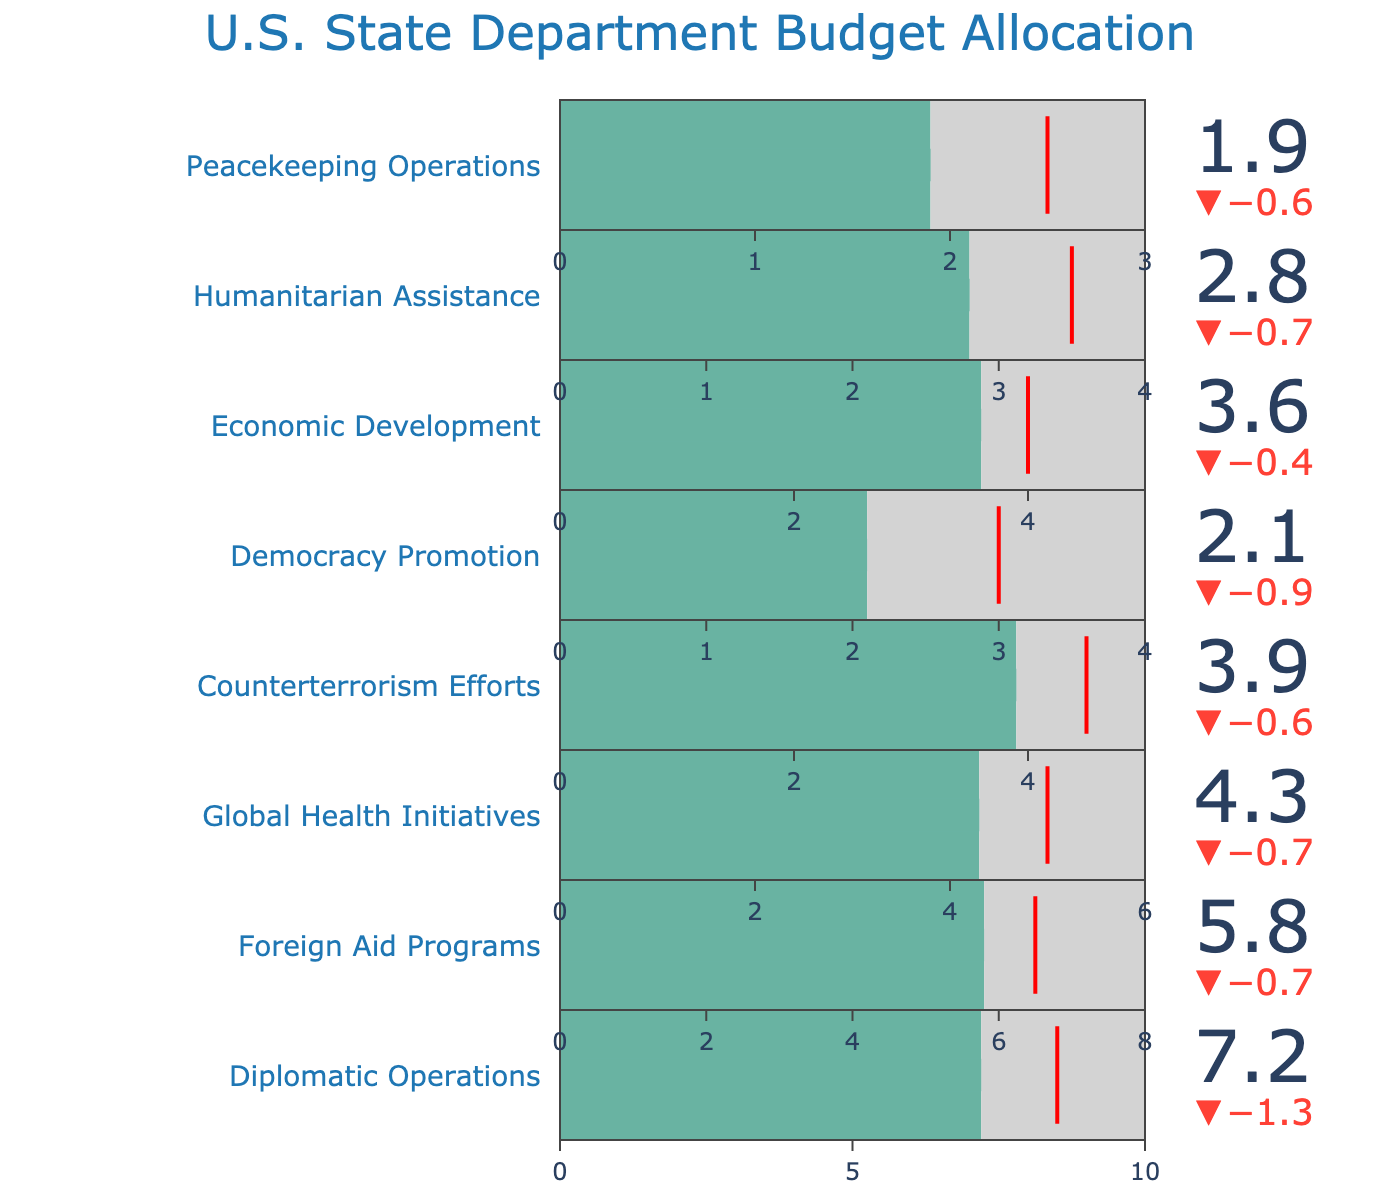What is the actual budget for Diplomatic Operations? The figure shows Diplomatic Operations with an actual budget value indicator. By looking at the actual value in the bullet chart for Diplomatic Operations, we can see it is 7.2.
Answer: 7.2 What category has the largest difference between actual spending and target spending? To determine the category with the largest difference, we need to compare the delta values (the difference) for each category. The differences are as follows: Diplomatic Operations: 1.3 (8.5 - 7.2), Foreign Aid Programs: 0.7 (6.5 - 5.8), Global Health Initiatives: 0.7 (5.0 - 4.3), Counterterrorism Efforts: 0.6 (4.5 - 3.9), Democracy Promotion: 0.9 (3.0 - 2.1), Economic Development: 0.4 (4.0 - 3.6), Humanitarian Assistance: 0.7 (3.5 - 2.8), Peacekeeping Operations: 0.6 (2.5 - 1.9). Therefore, Diplomatic Operations has the largest difference (1.3).
Answer: Diplomatic Operations Which category's actual budget is closest to its target? To find which category's actual spending is closest to its target, we check the smallest delta. Foreign Aid Programs, Global Health Initiatives, Counterterrorism Efforts, and Humanitarian Assistance each have a delta of 0.7. These categories have the closest actual budgets to their targets.
Answer: Foreign Aid Programs, Global Health Initiatives, Counterterrorism Efforts, Humanitarian Assistance How much more budget would need to be allocated to reach the target for Global Health Initiatives? We can find this by subtracting the actual budget from the target budget for Global Health Initiatives. The target is 5.0 and the actual is 4.3, so 5.0 - 4.3 = 0.7.
Answer: 0.7 What is the total actual budget for all categories? Sum the actual values of all categories from the chart: 7.2 + 5.8 + 4.3 + 3.9 + 2.1 + 3.6 + 2.8 + 1.9. The total is 7.2 + 5.8 + 4.3 + 3.9 + 2.1 + 3.6 + 2.8 + 1.9 = 31.6.
Answer: 31.6 Which category has the smallest maximum funding allocation? We need to check the maximum funding values for each category in the chart. By examining the values (10, 8, 6, 5, 4, 5, 4, 3), we can see that Peacekeeping Operations has the smallest max funding allocation, which is 3.
Answer: Peacekeeping Operations What is the range of funding for Counterterrorism Efforts? The range is the difference between the maximum and minimum values. For Counterterrorism Efforts, the maximum value is 5 and the actual value is 3.9, so the range is 5 - 3.9 = 1.1.
Answer: 1.1 Which categories exceeded half of their maximum allocation in actual spending? We need to check the categories where actual spending is more than half of the maximum allocation. Diplomatic Operations (7.2 of 10), Foreign Aid Programs (5.8 of 8), Global Health Initiatives (4.3 of 6), Counterterrorism Efforts (3.9 of 5), Economic Development (3.6 of 5), and Humanitarian Assistance (2.8 of 4) all meet this criterion.
Answer: Diplomatic Operations, Foreign Aid Programs, Global Health Initiatives, Counterterrorism Efforts, Economic Development, Humanitarian Assistance 